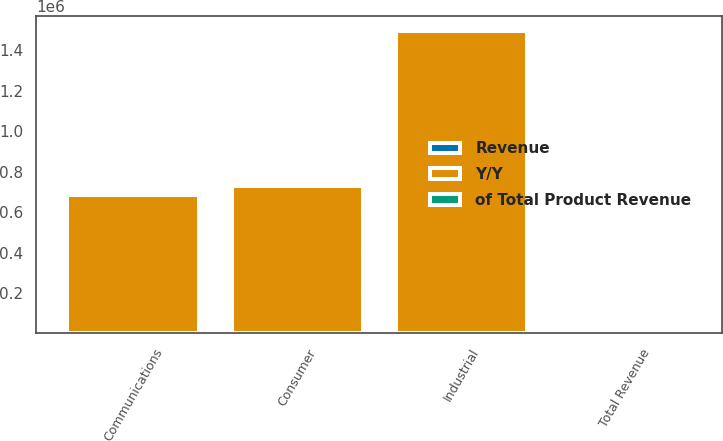<chart> <loc_0><loc_0><loc_500><loc_500><stacked_bar_chart><ecel><fcel>Industrial<fcel>Consumer<fcel>Communications<fcel>Total Revenue<nl><fcel>Y/Y<fcel>1.4962e+06<fcel>729965<fcel>682805<fcel>44<nl><fcel>of Total Product Revenue<fcel>44<fcel>21<fcel>20<fcel>100<nl><fcel>Revenue<fcel>11<fcel>123<fcel>2<fcel>20<nl></chart> 